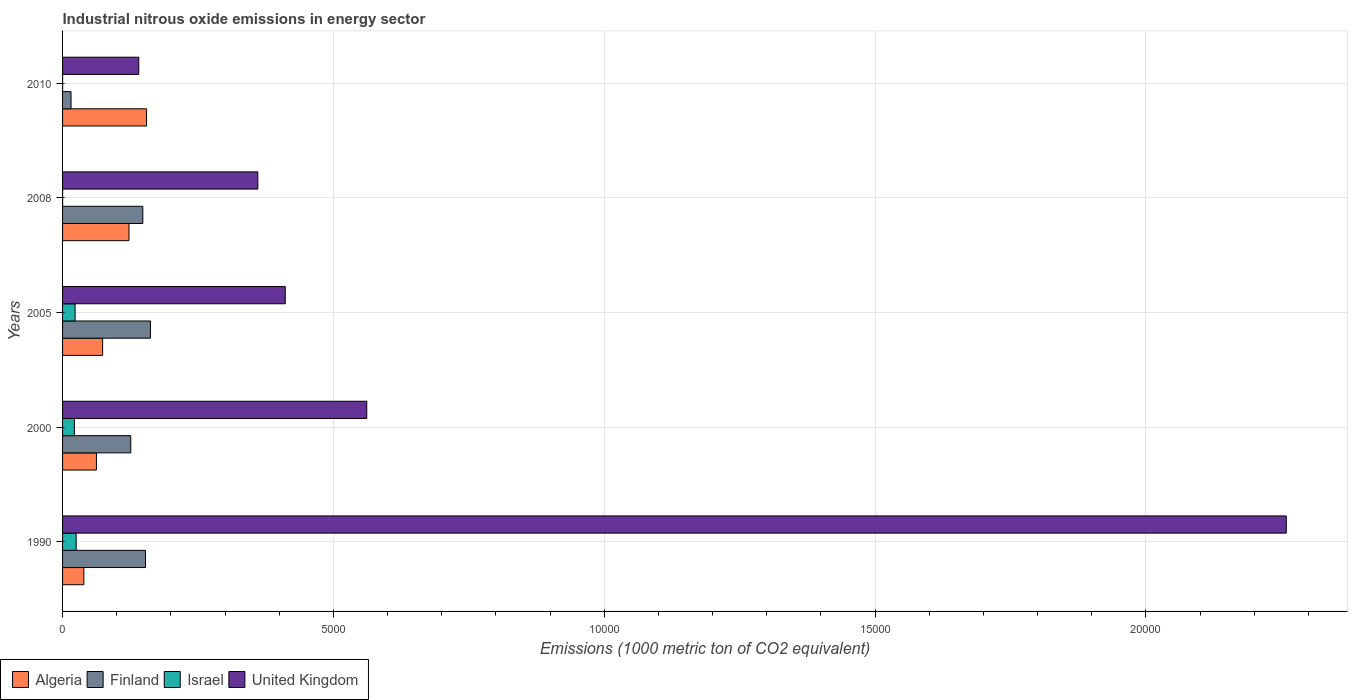How many different coloured bars are there?
Ensure brevity in your answer.  4. How many groups of bars are there?
Provide a succinct answer. 5. Are the number of bars per tick equal to the number of legend labels?
Give a very brief answer. Yes. Are the number of bars on each tick of the Y-axis equal?
Keep it short and to the point. Yes. How many bars are there on the 2nd tick from the top?
Offer a very short reply. 4. What is the label of the 4th group of bars from the top?
Your answer should be very brief. 2000. What is the amount of industrial nitrous oxide emitted in Algeria in 1990?
Ensure brevity in your answer.  393.4. Across all years, what is the maximum amount of industrial nitrous oxide emitted in Finland?
Your answer should be very brief. 1622.4. Across all years, what is the minimum amount of industrial nitrous oxide emitted in Algeria?
Make the answer very short. 393.4. In which year was the amount of industrial nitrous oxide emitted in Algeria maximum?
Offer a terse response. 2010. What is the total amount of industrial nitrous oxide emitted in Algeria in the graph?
Keep it short and to the point. 4534.8. What is the difference between the amount of industrial nitrous oxide emitted in Finland in 2000 and that in 2008?
Ensure brevity in your answer.  -222.1. What is the difference between the amount of industrial nitrous oxide emitted in Finland in 2000 and the amount of industrial nitrous oxide emitted in United Kingdom in 2008?
Your answer should be compact. -2345.2. What is the average amount of industrial nitrous oxide emitted in United Kingdom per year?
Make the answer very short. 7466.28. In the year 2005, what is the difference between the amount of industrial nitrous oxide emitted in Algeria and amount of industrial nitrous oxide emitted in Finland?
Keep it short and to the point. -882.8. What is the ratio of the amount of industrial nitrous oxide emitted in Finland in 2000 to that in 2008?
Provide a short and direct response. 0.85. Is the difference between the amount of industrial nitrous oxide emitted in Algeria in 1990 and 2005 greater than the difference between the amount of industrial nitrous oxide emitted in Finland in 1990 and 2005?
Give a very brief answer. No. What is the difference between the highest and the second highest amount of industrial nitrous oxide emitted in Finland?
Give a very brief answer. 91.5. What is the difference between the highest and the lowest amount of industrial nitrous oxide emitted in United Kingdom?
Provide a short and direct response. 2.12e+04. Is the sum of the amount of industrial nitrous oxide emitted in United Kingdom in 1990 and 2005 greater than the maximum amount of industrial nitrous oxide emitted in Israel across all years?
Your answer should be very brief. Yes. What does the 3rd bar from the top in 1990 represents?
Give a very brief answer. Finland. What does the 1st bar from the bottom in 2000 represents?
Your response must be concise. Algeria. Is it the case that in every year, the sum of the amount of industrial nitrous oxide emitted in United Kingdom and amount of industrial nitrous oxide emitted in Israel is greater than the amount of industrial nitrous oxide emitted in Algeria?
Offer a very short reply. No. Are all the bars in the graph horizontal?
Offer a very short reply. Yes. Does the graph contain any zero values?
Give a very brief answer. No. Does the graph contain grids?
Offer a terse response. Yes. Where does the legend appear in the graph?
Offer a terse response. Bottom left. What is the title of the graph?
Your answer should be very brief. Industrial nitrous oxide emissions in energy sector. What is the label or title of the X-axis?
Ensure brevity in your answer.  Emissions (1000 metric ton of CO2 equivalent). What is the Emissions (1000 metric ton of CO2 equivalent) in Algeria in 1990?
Your answer should be very brief. 393.4. What is the Emissions (1000 metric ton of CO2 equivalent) in Finland in 1990?
Your answer should be very brief. 1530.9. What is the Emissions (1000 metric ton of CO2 equivalent) of Israel in 1990?
Your response must be concise. 251.1. What is the Emissions (1000 metric ton of CO2 equivalent) of United Kingdom in 1990?
Give a very brief answer. 2.26e+04. What is the Emissions (1000 metric ton of CO2 equivalent) in Algeria in 2000?
Offer a terse response. 625. What is the Emissions (1000 metric ton of CO2 equivalent) of Finland in 2000?
Your answer should be very brief. 1259.4. What is the Emissions (1000 metric ton of CO2 equivalent) in Israel in 2000?
Provide a short and direct response. 217.6. What is the Emissions (1000 metric ton of CO2 equivalent) in United Kingdom in 2000?
Keep it short and to the point. 5616. What is the Emissions (1000 metric ton of CO2 equivalent) in Algeria in 2005?
Make the answer very short. 739.6. What is the Emissions (1000 metric ton of CO2 equivalent) in Finland in 2005?
Make the answer very short. 1622.4. What is the Emissions (1000 metric ton of CO2 equivalent) of Israel in 2005?
Give a very brief answer. 231.6. What is the Emissions (1000 metric ton of CO2 equivalent) of United Kingdom in 2005?
Ensure brevity in your answer.  4111.2. What is the Emissions (1000 metric ton of CO2 equivalent) of Algeria in 2008?
Provide a succinct answer. 1226.2. What is the Emissions (1000 metric ton of CO2 equivalent) of Finland in 2008?
Make the answer very short. 1481.5. What is the Emissions (1000 metric ton of CO2 equivalent) of United Kingdom in 2008?
Provide a succinct answer. 3604.6. What is the Emissions (1000 metric ton of CO2 equivalent) of Algeria in 2010?
Offer a very short reply. 1550.6. What is the Emissions (1000 metric ton of CO2 equivalent) in Finland in 2010?
Keep it short and to the point. 156.3. What is the Emissions (1000 metric ton of CO2 equivalent) in Israel in 2010?
Your answer should be compact. 0.6. What is the Emissions (1000 metric ton of CO2 equivalent) of United Kingdom in 2010?
Make the answer very short. 1406.6. Across all years, what is the maximum Emissions (1000 metric ton of CO2 equivalent) in Algeria?
Provide a succinct answer. 1550.6. Across all years, what is the maximum Emissions (1000 metric ton of CO2 equivalent) of Finland?
Provide a succinct answer. 1622.4. Across all years, what is the maximum Emissions (1000 metric ton of CO2 equivalent) in Israel?
Make the answer very short. 251.1. Across all years, what is the maximum Emissions (1000 metric ton of CO2 equivalent) of United Kingdom?
Keep it short and to the point. 2.26e+04. Across all years, what is the minimum Emissions (1000 metric ton of CO2 equivalent) in Algeria?
Your response must be concise. 393.4. Across all years, what is the minimum Emissions (1000 metric ton of CO2 equivalent) of Finland?
Your answer should be compact. 156.3. Across all years, what is the minimum Emissions (1000 metric ton of CO2 equivalent) of United Kingdom?
Ensure brevity in your answer.  1406.6. What is the total Emissions (1000 metric ton of CO2 equivalent) of Algeria in the graph?
Your answer should be very brief. 4534.8. What is the total Emissions (1000 metric ton of CO2 equivalent) of Finland in the graph?
Your answer should be compact. 6050.5. What is the total Emissions (1000 metric ton of CO2 equivalent) of Israel in the graph?
Provide a short and direct response. 701.9. What is the total Emissions (1000 metric ton of CO2 equivalent) of United Kingdom in the graph?
Your answer should be very brief. 3.73e+04. What is the difference between the Emissions (1000 metric ton of CO2 equivalent) in Algeria in 1990 and that in 2000?
Provide a short and direct response. -231.6. What is the difference between the Emissions (1000 metric ton of CO2 equivalent) of Finland in 1990 and that in 2000?
Provide a succinct answer. 271.5. What is the difference between the Emissions (1000 metric ton of CO2 equivalent) in Israel in 1990 and that in 2000?
Make the answer very short. 33.5. What is the difference between the Emissions (1000 metric ton of CO2 equivalent) of United Kingdom in 1990 and that in 2000?
Offer a terse response. 1.70e+04. What is the difference between the Emissions (1000 metric ton of CO2 equivalent) in Algeria in 1990 and that in 2005?
Provide a succinct answer. -346.2. What is the difference between the Emissions (1000 metric ton of CO2 equivalent) in Finland in 1990 and that in 2005?
Offer a very short reply. -91.5. What is the difference between the Emissions (1000 metric ton of CO2 equivalent) of United Kingdom in 1990 and that in 2005?
Provide a succinct answer. 1.85e+04. What is the difference between the Emissions (1000 metric ton of CO2 equivalent) of Algeria in 1990 and that in 2008?
Offer a very short reply. -832.8. What is the difference between the Emissions (1000 metric ton of CO2 equivalent) in Finland in 1990 and that in 2008?
Make the answer very short. 49.4. What is the difference between the Emissions (1000 metric ton of CO2 equivalent) of Israel in 1990 and that in 2008?
Make the answer very short. 250.1. What is the difference between the Emissions (1000 metric ton of CO2 equivalent) in United Kingdom in 1990 and that in 2008?
Keep it short and to the point. 1.90e+04. What is the difference between the Emissions (1000 metric ton of CO2 equivalent) in Algeria in 1990 and that in 2010?
Give a very brief answer. -1157.2. What is the difference between the Emissions (1000 metric ton of CO2 equivalent) of Finland in 1990 and that in 2010?
Offer a terse response. 1374.6. What is the difference between the Emissions (1000 metric ton of CO2 equivalent) in Israel in 1990 and that in 2010?
Your answer should be very brief. 250.5. What is the difference between the Emissions (1000 metric ton of CO2 equivalent) in United Kingdom in 1990 and that in 2010?
Give a very brief answer. 2.12e+04. What is the difference between the Emissions (1000 metric ton of CO2 equivalent) in Algeria in 2000 and that in 2005?
Offer a terse response. -114.6. What is the difference between the Emissions (1000 metric ton of CO2 equivalent) of Finland in 2000 and that in 2005?
Keep it short and to the point. -363. What is the difference between the Emissions (1000 metric ton of CO2 equivalent) of Israel in 2000 and that in 2005?
Provide a succinct answer. -14. What is the difference between the Emissions (1000 metric ton of CO2 equivalent) in United Kingdom in 2000 and that in 2005?
Offer a very short reply. 1504.8. What is the difference between the Emissions (1000 metric ton of CO2 equivalent) of Algeria in 2000 and that in 2008?
Your answer should be compact. -601.2. What is the difference between the Emissions (1000 metric ton of CO2 equivalent) of Finland in 2000 and that in 2008?
Make the answer very short. -222.1. What is the difference between the Emissions (1000 metric ton of CO2 equivalent) of Israel in 2000 and that in 2008?
Give a very brief answer. 216.6. What is the difference between the Emissions (1000 metric ton of CO2 equivalent) of United Kingdom in 2000 and that in 2008?
Make the answer very short. 2011.4. What is the difference between the Emissions (1000 metric ton of CO2 equivalent) in Algeria in 2000 and that in 2010?
Your answer should be compact. -925.6. What is the difference between the Emissions (1000 metric ton of CO2 equivalent) of Finland in 2000 and that in 2010?
Your answer should be compact. 1103.1. What is the difference between the Emissions (1000 metric ton of CO2 equivalent) of Israel in 2000 and that in 2010?
Offer a very short reply. 217. What is the difference between the Emissions (1000 metric ton of CO2 equivalent) of United Kingdom in 2000 and that in 2010?
Offer a terse response. 4209.4. What is the difference between the Emissions (1000 metric ton of CO2 equivalent) of Algeria in 2005 and that in 2008?
Make the answer very short. -486.6. What is the difference between the Emissions (1000 metric ton of CO2 equivalent) of Finland in 2005 and that in 2008?
Make the answer very short. 140.9. What is the difference between the Emissions (1000 metric ton of CO2 equivalent) in Israel in 2005 and that in 2008?
Your answer should be compact. 230.6. What is the difference between the Emissions (1000 metric ton of CO2 equivalent) of United Kingdom in 2005 and that in 2008?
Provide a succinct answer. 506.6. What is the difference between the Emissions (1000 metric ton of CO2 equivalent) in Algeria in 2005 and that in 2010?
Offer a terse response. -811. What is the difference between the Emissions (1000 metric ton of CO2 equivalent) of Finland in 2005 and that in 2010?
Keep it short and to the point. 1466.1. What is the difference between the Emissions (1000 metric ton of CO2 equivalent) of Israel in 2005 and that in 2010?
Your answer should be compact. 231. What is the difference between the Emissions (1000 metric ton of CO2 equivalent) of United Kingdom in 2005 and that in 2010?
Your answer should be compact. 2704.6. What is the difference between the Emissions (1000 metric ton of CO2 equivalent) in Algeria in 2008 and that in 2010?
Offer a very short reply. -324.4. What is the difference between the Emissions (1000 metric ton of CO2 equivalent) of Finland in 2008 and that in 2010?
Offer a terse response. 1325.2. What is the difference between the Emissions (1000 metric ton of CO2 equivalent) in United Kingdom in 2008 and that in 2010?
Make the answer very short. 2198. What is the difference between the Emissions (1000 metric ton of CO2 equivalent) in Algeria in 1990 and the Emissions (1000 metric ton of CO2 equivalent) in Finland in 2000?
Give a very brief answer. -866. What is the difference between the Emissions (1000 metric ton of CO2 equivalent) in Algeria in 1990 and the Emissions (1000 metric ton of CO2 equivalent) in Israel in 2000?
Ensure brevity in your answer.  175.8. What is the difference between the Emissions (1000 metric ton of CO2 equivalent) of Algeria in 1990 and the Emissions (1000 metric ton of CO2 equivalent) of United Kingdom in 2000?
Make the answer very short. -5222.6. What is the difference between the Emissions (1000 metric ton of CO2 equivalent) of Finland in 1990 and the Emissions (1000 metric ton of CO2 equivalent) of Israel in 2000?
Make the answer very short. 1313.3. What is the difference between the Emissions (1000 metric ton of CO2 equivalent) in Finland in 1990 and the Emissions (1000 metric ton of CO2 equivalent) in United Kingdom in 2000?
Your response must be concise. -4085.1. What is the difference between the Emissions (1000 metric ton of CO2 equivalent) of Israel in 1990 and the Emissions (1000 metric ton of CO2 equivalent) of United Kingdom in 2000?
Make the answer very short. -5364.9. What is the difference between the Emissions (1000 metric ton of CO2 equivalent) of Algeria in 1990 and the Emissions (1000 metric ton of CO2 equivalent) of Finland in 2005?
Make the answer very short. -1229. What is the difference between the Emissions (1000 metric ton of CO2 equivalent) of Algeria in 1990 and the Emissions (1000 metric ton of CO2 equivalent) of Israel in 2005?
Give a very brief answer. 161.8. What is the difference between the Emissions (1000 metric ton of CO2 equivalent) of Algeria in 1990 and the Emissions (1000 metric ton of CO2 equivalent) of United Kingdom in 2005?
Make the answer very short. -3717.8. What is the difference between the Emissions (1000 metric ton of CO2 equivalent) in Finland in 1990 and the Emissions (1000 metric ton of CO2 equivalent) in Israel in 2005?
Your answer should be very brief. 1299.3. What is the difference between the Emissions (1000 metric ton of CO2 equivalent) in Finland in 1990 and the Emissions (1000 metric ton of CO2 equivalent) in United Kingdom in 2005?
Provide a succinct answer. -2580.3. What is the difference between the Emissions (1000 metric ton of CO2 equivalent) of Israel in 1990 and the Emissions (1000 metric ton of CO2 equivalent) of United Kingdom in 2005?
Provide a succinct answer. -3860.1. What is the difference between the Emissions (1000 metric ton of CO2 equivalent) in Algeria in 1990 and the Emissions (1000 metric ton of CO2 equivalent) in Finland in 2008?
Offer a very short reply. -1088.1. What is the difference between the Emissions (1000 metric ton of CO2 equivalent) of Algeria in 1990 and the Emissions (1000 metric ton of CO2 equivalent) of Israel in 2008?
Give a very brief answer. 392.4. What is the difference between the Emissions (1000 metric ton of CO2 equivalent) of Algeria in 1990 and the Emissions (1000 metric ton of CO2 equivalent) of United Kingdom in 2008?
Offer a terse response. -3211.2. What is the difference between the Emissions (1000 metric ton of CO2 equivalent) in Finland in 1990 and the Emissions (1000 metric ton of CO2 equivalent) in Israel in 2008?
Your answer should be compact. 1529.9. What is the difference between the Emissions (1000 metric ton of CO2 equivalent) of Finland in 1990 and the Emissions (1000 metric ton of CO2 equivalent) of United Kingdom in 2008?
Keep it short and to the point. -2073.7. What is the difference between the Emissions (1000 metric ton of CO2 equivalent) of Israel in 1990 and the Emissions (1000 metric ton of CO2 equivalent) of United Kingdom in 2008?
Your answer should be compact. -3353.5. What is the difference between the Emissions (1000 metric ton of CO2 equivalent) of Algeria in 1990 and the Emissions (1000 metric ton of CO2 equivalent) of Finland in 2010?
Make the answer very short. 237.1. What is the difference between the Emissions (1000 metric ton of CO2 equivalent) of Algeria in 1990 and the Emissions (1000 metric ton of CO2 equivalent) of Israel in 2010?
Provide a succinct answer. 392.8. What is the difference between the Emissions (1000 metric ton of CO2 equivalent) of Algeria in 1990 and the Emissions (1000 metric ton of CO2 equivalent) of United Kingdom in 2010?
Offer a terse response. -1013.2. What is the difference between the Emissions (1000 metric ton of CO2 equivalent) of Finland in 1990 and the Emissions (1000 metric ton of CO2 equivalent) of Israel in 2010?
Provide a succinct answer. 1530.3. What is the difference between the Emissions (1000 metric ton of CO2 equivalent) in Finland in 1990 and the Emissions (1000 metric ton of CO2 equivalent) in United Kingdom in 2010?
Offer a terse response. 124.3. What is the difference between the Emissions (1000 metric ton of CO2 equivalent) of Israel in 1990 and the Emissions (1000 metric ton of CO2 equivalent) of United Kingdom in 2010?
Provide a succinct answer. -1155.5. What is the difference between the Emissions (1000 metric ton of CO2 equivalent) in Algeria in 2000 and the Emissions (1000 metric ton of CO2 equivalent) in Finland in 2005?
Provide a succinct answer. -997.4. What is the difference between the Emissions (1000 metric ton of CO2 equivalent) of Algeria in 2000 and the Emissions (1000 metric ton of CO2 equivalent) of Israel in 2005?
Your response must be concise. 393.4. What is the difference between the Emissions (1000 metric ton of CO2 equivalent) in Algeria in 2000 and the Emissions (1000 metric ton of CO2 equivalent) in United Kingdom in 2005?
Ensure brevity in your answer.  -3486.2. What is the difference between the Emissions (1000 metric ton of CO2 equivalent) of Finland in 2000 and the Emissions (1000 metric ton of CO2 equivalent) of Israel in 2005?
Make the answer very short. 1027.8. What is the difference between the Emissions (1000 metric ton of CO2 equivalent) in Finland in 2000 and the Emissions (1000 metric ton of CO2 equivalent) in United Kingdom in 2005?
Make the answer very short. -2851.8. What is the difference between the Emissions (1000 metric ton of CO2 equivalent) of Israel in 2000 and the Emissions (1000 metric ton of CO2 equivalent) of United Kingdom in 2005?
Provide a succinct answer. -3893.6. What is the difference between the Emissions (1000 metric ton of CO2 equivalent) in Algeria in 2000 and the Emissions (1000 metric ton of CO2 equivalent) in Finland in 2008?
Your answer should be compact. -856.5. What is the difference between the Emissions (1000 metric ton of CO2 equivalent) of Algeria in 2000 and the Emissions (1000 metric ton of CO2 equivalent) of Israel in 2008?
Ensure brevity in your answer.  624. What is the difference between the Emissions (1000 metric ton of CO2 equivalent) in Algeria in 2000 and the Emissions (1000 metric ton of CO2 equivalent) in United Kingdom in 2008?
Ensure brevity in your answer.  -2979.6. What is the difference between the Emissions (1000 metric ton of CO2 equivalent) of Finland in 2000 and the Emissions (1000 metric ton of CO2 equivalent) of Israel in 2008?
Offer a terse response. 1258.4. What is the difference between the Emissions (1000 metric ton of CO2 equivalent) of Finland in 2000 and the Emissions (1000 metric ton of CO2 equivalent) of United Kingdom in 2008?
Give a very brief answer. -2345.2. What is the difference between the Emissions (1000 metric ton of CO2 equivalent) in Israel in 2000 and the Emissions (1000 metric ton of CO2 equivalent) in United Kingdom in 2008?
Provide a short and direct response. -3387. What is the difference between the Emissions (1000 metric ton of CO2 equivalent) of Algeria in 2000 and the Emissions (1000 metric ton of CO2 equivalent) of Finland in 2010?
Provide a succinct answer. 468.7. What is the difference between the Emissions (1000 metric ton of CO2 equivalent) of Algeria in 2000 and the Emissions (1000 metric ton of CO2 equivalent) of Israel in 2010?
Provide a succinct answer. 624.4. What is the difference between the Emissions (1000 metric ton of CO2 equivalent) in Algeria in 2000 and the Emissions (1000 metric ton of CO2 equivalent) in United Kingdom in 2010?
Ensure brevity in your answer.  -781.6. What is the difference between the Emissions (1000 metric ton of CO2 equivalent) of Finland in 2000 and the Emissions (1000 metric ton of CO2 equivalent) of Israel in 2010?
Your answer should be very brief. 1258.8. What is the difference between the Emissions (1000 metric ton of CO2 equivalent) of Finland in 2000 and the Emissions (1000 metric ton of CO2 equivalent) of United Kingdom in 2010?
Provide a succinct answer. -147.2. What is the difference between the Emissions (1000 metric ton of CO2 equivalent) of Israel in 2000 and the Emissions (1000 metric ton of CO2 equivalent) of United Kingdom in 2010?
Your answer should be very brief. -1189. What is the difference between the Emissions (1000 metric ton of CO2 equivalent) in Algeria in 2005 and the Emissions (1000 metric ton of CO2 equivalent) in Finland in 2008?
Provide a short and direct response. -741.9. What is the difference between the Emissions (1000 metric ton of CO2 equivalent) in Algeria in 2005 and the Emissions (1000 metric ton of CO2 equivalent) in Israel in 2008?
Provide a succinct answer. 738.6. What is the difference between the Emissions (1000 metric ton of CO2 equivalent) of Algeria in 2005 and the Emissions (1000 metric ton of CO2 equivalent) of United Kingdom in 2008?
Keep it short and to the point. -2865. What is the difference between the Emissions (1000 metric ton of CO2 equivalent) in Finland in 2005 and the Emissions (1000 metric ton of CO2 equivalent) in Israel in 2008?
Give a very brief answer. 1621.4. What is the difference between the Emissions (1000 metric ton of CO2 equivalent) in Finland in 2005 and the Emissions (1000 metric ton of CO2 equivalent) in United Kingdom in 2008?
Offer a terse response. -1982.2. What is the difference between the Emissions (1000 metric ton of CO2 equivalent) of Israel in 2005 and the Emissions (1000 metric ton of CO2 equivalent) of United Kingdom in 2008?
Keep it short and to the point. -3373. What is the difference between the Emissions (1000 metric ton of CO2 equivalent) in Algeria in 2005 and the Emissions (1000 metric ton of CO2 equivalent) in Finland in 2010?
Ensure brevity in your answer.  583.3. What is the difference between the Emissions (1000 metric ton of CO2 equivalent) of Algeria in 2005 and the Emissions (1000 metric ton of CO2 equivalent) of Israel in 2010?
Offer a very short reply. 739. What is the difference between the Emissions (1000 metric ton of CO2 equivalent) of Algeria in 2005 and the Emissions (1000 metric ton of CO2 equivalent) of United Kingdom in 2010?
Keep it short and to the point. -667. What is the difference between the Emissions (1000 metric ton of CO2 equivalent) of Finland in 2005 and the Emissions (1000 metric ton of CO2 equivalent) of Israel in 2010?
Your answer should be compact. 1621.8. What is the difference between the Emissions (1000 metric ton of CO2 equivalent) in Finland in 2005 and the Emissions (1000 metric ton of CO2 equivalent) in United Kingdom in 2010?
Provide a succinct answer. 215.8. What is the difference between the Emissions (1000 metric ton of CO2 equivalent) of Israel in 2005 and the Emissions (1000 metric ton of CO2 equivalent) of United Kingdom in 2010?
Provide a short and direct response. -1175. What is the difference between the Emissions (1000 metric ton of CO2 equivalent) in Algeria in 2008 and the Emissions (1000 metric ton of CO2 equivalent) in Finland in 2010?
Keep it short and to the point. 1069.9. What is the difference between the Emissions (1000 metric ton of CO2 equivalent) of Algeria in 2008 and the Emissions (1000 metric ton of CO2 equivalent) of Israel in 2010?
Provide a short and direct response. 1225.6. What is the difference between the Emissions (1000 metric ton of CO2 equivalent) in Algeria in 2008 and the Emissions (1000 metric ton of CO2 equivalent) in United Kingdom in 2010?
Keep it short and to the point. -180.4. What is the difference between the Emissions (1000 metric ton of CO2 equivalent) of Finland in 2008 and the Emissions (1000 metric ton of CO2 equivalent) of Israel in 2010?
Give a very brief answer. 1480.9. What is the difference between the Emissions (1000 metric ton of CO2 equivalent) of Finland in 2008 and the Emissions (1000 metric ton of CO2 equivalent) of United Kingdom in 2010?
Offer a terse response. 74.9. What is the difference between the Emissions (1000 metric ton of CO2 equivalent) in Israel in 2008 and the Emissions (1000 metric ton of CO2 equivalent) in United Kingdom in 2010?
Your response must be concise. -1405.6. What is the average Emissions (1000 metric ton of CO2 equivalent) in Algeria per year?
Ensure brevity in your answer.  906.96. What is the average Emissions (1000 metric ton of CO2 equivalent) of Finland per year?
Your response must be concise. 1210.1. What is the average Emissions (1000 metric ton of CO2 equivalent) in Israel per year?
Your answer should be very brief. 140.38. What is the average Emissions (1000 metric ton of CO2 equivalent) in United Kingdom per year?
Give a very brief answer. 7466.28. In the year 1990, what is the difference between the Emissions (1000 metric ton of CO2 equivalent) of Algeria and Emissions (1000 metric ton of CO2 equivalent) of Finland?
Your answer should be very brief. -1137.5. In the year 1990, what is the difference between the Emissions (1000 metric ton of CO2 equivalent) of Algeria and Emissions (1000 metric ton of CO2 equivalent) of Israel?
Ensure brevity in your answer.  142.3. In the year 1990, what is the difference between the Emissions (1000 metric ton of CO2 equivalent) in Algeria and Emissions (1000 metric ton of CO2 equivalent) in United Kingdom?
Provide a short and direct response. -2.22e+04. In the year 1990, what is the difference between the Emissions (1000 metric ton of CO2 equivalent) of Finland and Emissions (1000 metric ton of CO2 equivalent) of Israel?
Your response must be concise. 1279.8. In the year 1990, what is the difference between the Emissions (1000 metric ton of CO2 equivalent) of Finland and Emissions (1000 metric ton of CO2 equivalent) of United Kingdom?
Provide a short and direct response. -2.11e+04. In the year 1990, what is the difference between the Emissions (1000 metric ton of CO2 equivalent) in Israel and Emissions (1000 metric ton of CO2 equivalent) in United Kingdom?
Make the answer very short. -2.23e+04. In the year 2000, what is the difference between the Emissions (1000 metric ton of CO2 equivalent) in Algeria and Emissions (1000 metric ton of CO2 equivalent) in Finland?
Your answer should be very brief. -634.4. In the year 2000, what is the difference between the Emissions (1000 metric ton of CO2 equivalent) of Algeria and Emissions (1000 metric ton of CO2 equivalent) of Israel?
Offer a very short reply. 407.4. In the year 2000, what is the difference between the Emissions (1000 metric ton of CO2 equivalent) in Algeria and Emissions (1000 metric ton of CO2 equivalent) in United Kingdom?
Offer a very short reply. -4991. In the year 2000, what is the difference between the Emissions (1000 metric ton of CO2 equivalent) of Finland and Emissions (1000 metric ton of CO2 equivalent) of Israel?
Your response must be concise. 1041.8. In the year 2000, what is the difference between the Emissions (1000 metric ton of CO2 equivalent) in Finland and Emissions (1000 metric ton of CO2 equivalent) in United Kingdom?
Ensure brevity in your answer.  -4356.6. In the year 2000, what is the difference between the Emissions (1000 metric ton of CO2 equivalent) in Israel and Emissions (1000 metric ton of CO2 equivalent) in United Kingdom?
Your response must be concise. -5398.4. In the year 2005, what is the difference between the Emissions (1000 metric ton of CO2 equivalent) of Algeria and Emissions (1000 metric ton of CO2 equivalent) of Finland?
Offer a terse response. -882.8. In the year 2005, what is the difference between the Emissions (1000 metric ton of CO2 equivalent) in Algeria and Emissions (1000 metric ton of CO2 equivalent) in Israel?
Your answer should be very brief. 508. In the year 2005, what is the difference between the Emissions (1000 metric ton of CO2 equivalent) of Algeria and Emissions (1000 metric ton of CO2 equivalent) of United Kingdom?
Offer a very short reply. -3371.6. In the year 2005, what is the difference between the Emissions (1000 metric ton of CO2 equivalent) in Finland and Emissions (1000 metric ton of CO2 equivalent) in Israel?
Ensure brevity in your answer.  1390.8. In the year 2005, what is the difference between the Emissions (1000 metric ton of CO2 equivalent) in Finland and Emissions (1000 metric ton of CO2 equivalent) in United Kingdom?
Offer a terse response. -2488.8. In the year 2005, what is the difference between the Emissions (1000 metric ton of CO2 equivalent) in Israel and Emissions (1000 metric ton of CO2 equivalent) in United Kingdom?
Your answer should be compact. -3879.6. In the year 2008, what is the difference between the Emissions (1000 metric ton of CO2 equivalent) in Algeria and Emissions (1000 metric ton of CO2 equivalent) in Finland?
Offer a terse response. -255.3. In the year 2008, what is the difference between the Emissions (1000 metric ton of CO2 equivalent) of Algeria and Emissions (1000 metric ton of CO2 equivalent) of Israel?
Ensure brevity in your answer.  1225.2. In the year 2008, what is the difference between the Emissions (1000 metric ton of CO2 equivalent) in Algeria and Emissions (1000 metric ton of CO2 equivalent) in United Kingdom?
Make the answer very short. -2378.4. In the year 2008, what is the difference between the Emissions (1000 metric ton of CO2 equivalent) of Finland and Emissions (1000 metric ton of CO2 equivalent) of Israel?
Make the answer very short. 1480.5. In the year 2008, what is the difference between the Emissions (1000 metric ton of CO2 equivalent) in Finland and Emissions (1000 metric ton of CO2 equivalent) in United Kingdom?
Keep it short and to the point. -2123.1. In the year 2008, what is the difference between the Emissions (1000 metric ton of CO2 equivalent) of Israel and Emissions (1000 metric ton of CO2 equivalent) of United Kingdom?
Provide a succinct answer. -3603.6. In the year 2010, what is the difference between the Emissions (1000 metric ton of CO2 equivalent) of Algeria and Emissions (1000 metric ton of CO2 equivalent) of Finland?
Provide a short and direct response. 1394.3. In the year 2010, what is the difference between the Emissions (1000 metric ton of CO2 equivalent) in Algeria and Emissions (1000 metric ton of CO2 equivalent) in Israel?
Ensure brevity in your answer.  1550. In the year 2010, what is the difference between the Emissions (1000 metric ton of CO2 equivalent) of Algeria and Emissions (1000 metric ton of CO2 equivalent) of United Kingdom?
Your answer should be compact. 144. In the year 2010, what is the difference between the Emissions (1000 metric ton of CO2 equivalent) in Finland and Emissions (1000 metric ton of CO2 equivalent) in Israel?
Ensure brevity in your answer.  155.7. In the year 2010, what is the difference between the Emissions (1000 metric ton of CO2 equivalent) in Finland and Emissions (1000 metric ton of CO2 equivalent) in United Kingdom?
Your answer should be compact. -1250.3. In the year 2010, what is the difference between the Emissions (1000 metric ton of CO2 equivalent) of Israel and Emissions (1000 metric ton of CO2 equivalent) of United Kingdom?
Your answer should be very brief. -1406. What is the ratio of the Emissions (1000 metric ton of CO2 equivalent) in Algeria in 1990 to that in 2000?
Your response must be concise. 0.63. What is the ratio of the Emissions (1000 metric ton of CO2 equivalent) of Finland in 1990 to that in 2000?
Your answer should be compact. 1.22. What is the ratio of the Emissions (1000 metric ton of CO2 equivalent) in Israel in 1990 to that in 2000?
Give a very brief answer. 1.15. What is the ratio of the Emissions (1000 metric ton of CO2 equivalent) in United Kingdom in 1990 to that in 2000?
Provide a succinct answer. 4.02. What is the ratio of the Emissions (1000 metric ton of CO2 equivalent) in Algeria in 1990 to that in 2005?
Your answer should be compact. 0.53. What is the ratio of the Emissions (1000 metric ton of CO2 equivalent) of Finland in 1990 to that in 2005?
Your answer should be very brief. 0.94. What is the ratio of the Emissions (1000 metric ton of CO2 equivalent) in Israel in 1990 to that in 2005?
Your answer should be compact. 1.08. What is the ratio of the Emissions (1000 metric ton of CO2 equivalent) of United Kingdom in 1990 to that in 2005?
Make the answer very short. 5.5. What is the ratio of the Emissions (1000 metric ton of CO2 equivalent) in Algeria in 1990 to that in 2008?
Your answer should be compact. 0.32. What is the ratio of the Emissions (1000 metric ton of CO2 equivalent) of Finland in 1990 to that in 2008?
Offer a terse response. 1.03. What is the ratio of the Emissions (1000 metric ton of CO2 equivalent) of Israel in 1990 to that in 2008?
Your answer should be compact. 251.1. What is the ratio of the Emissions (1000 metric ton of CO2 equivalent) in United Kingdom in 1990 to that in 2008?
Offer a terse response. 6.27. What is the ratio of the Emissions (1000 metric ton of CO2 equivalent) of Algeria in 1990 to that in 2010?
Your answer should be compact. 0.25. What is the ratio of the Emissions (1000 metric ton of CO2 equivalent) of Finland in 1990 to that in 2010?
Offer a terse response. 9.79. What is the ratio of the Emissions (1000 metric ton of CO2 equivalent) in Israel in 1990 to that in 2010?
Make the answer very short. 418.5. What is the ratio of the Emissions (1000 metric ton of CO2 equivalent) in United Kingdom in 1990 to that in 2010?
Offer a very short reply. 16.06. What is the ratio of the Emissions (1000 metric ton of CO2 equivalent) in Algeria in 2000 to that in 2005?
Ensure brevity in your answer.  0.85. What is the ratio of the Emissions (1000 metric ton of CO2 equivalent) of Finland in 2000 to that in 2005?
Keep it short and to the point. 0.78. What is the ratio of the Emissions (1000 metric ton of CO2 equivalent) in Israel in 2000 to that in 2005?
Your answer should be compact. 0.94. What is the ratio of the Emissions (1000 metric ton of CO2 equivalent) of United Kingdom in 2000 to that in 2005?
Give a very brief answer. 1.37. What is the ratio of the Emissions (1000 metric ton of CO2 equivalent) of Algeria in 2000 to that in 2008?
Provide a succinct answer. 0.51. What is the ratio of the Emissions (1000 metric ton of CO2 equivalent) of Finland in 2000 to that in 2008?
Provide a short and direct response. 0.85. What is the ratio of the Emissions (1000 metric ton of CO2 equivalent) in Israel in 2000 to that in 2008?
Ensure brevity in your answer.  217.6. What is the ratio of the Emissions (1000 metric ton of CO2 equivalent) in United Kingdom in 2000 to that in 2008?
Your answer should be very brief. 1.56. What is the ratio of the Emissions (1000 metric ton of CO2 equivalent) in Algeria in 2000 to that in 2010?
Make the answer very short. 0.4. What is the ratio of the Emissions (1000 metric ton of CO2 equivalent) in Finland in 2000 to that in 2010?
Offer a very short reply. 8.06. What is the ratio of the Emissions (1000 metric ton of CO2 equivalent) in Israel in 2000 to that in 2010?
Offer a terse response. 362.67. What is the ratio of the Emissions (1000 metric ton of CO2 equivalent) in United Kingdom in 2000 to that in 2010?
Keep it short and to the point. 3.99. What is the ratio of the Emissions (1000 metric ton of CO2 equivalent) in Algeria in 2005 to that in 2008?
Offer a very short reply. 0.6. What is the ratio of the Emissions (1000 metric ton of CO2 equivalent) of Finland in 2005 to that in 2008?
Your answer should be compact. 1.1. What is the ratio of the Emissions (1000 metric ton of CO2 equivalent) in Israel in 2005 to that in 2008?
Give a very brief answer. 231.6. What is the ratio of the Emissions (1000 metric ton of CO2 equivalent) of United Kingdom in 2005 to that in 2008?
Keep it short and to the point. 1.14. What is the ratio of the Emissions (1000 metric ton of CO2 equivalent) of Algeria in 2005 to that in 2010?
Your answer should be compact. 0.48. What is the ratio of the Emissions (1000 metric ton of CO2 equivalent) of Finland in 2005 to that in 2010?
Your answer should be compact. 10.38. What is the ratio of the Emissions (1000 metric ton of CO2 equivalent) of Israel in 2005 to that in 2010?
Your answer should be compact. 386. What is the ratio of the Emissions (1000 metric ton of CO2 equivalent) in United Kingdom in 2005 to that in 2010?
Provide a short and direct response. 2.92. What is the ratio of the Emissions (1000 metric ton of CO2 equivalent) in Algeria in 2008 to that in 2010?
Give a very brief answer. 0.79. What is the ratio of the Emissions (1000 metric ton of CO2 equivalent) of Finland in 2008 to that in 2010?
Make the answer very short. 9.48. What is the ratio of the Emissions (1000 metric ton of CO2 equivalent) in Israel in 2008 to that in 2010?
Provide a succinct answer. 1.67. What is the ratio of the Emissions (1000 metric ton of CO2 equivalent) of United Kingdom in 2008 to that in 2010?
Offer a very short reply. 2.56. What is the difference between the highest and the second highest Emissions (1000 metric ton of CO2 equivalent) in Algeria?
Offer a terse response. 324.4. What is the difference between the highest and the second highest Emissions (1000 metric ton of CO2 equivalent) in Finland?
Your answer should be compact. 91.5. What is the difference between the highest and the second highest Emissions (1000 metric ton of CO2 equivalent) of Israel?
Give a very brief answer. 19.5. What is the difference between the highest and the second highest Emissions (1000 metric ton of CO2 equivalent) of United Kingdom?
Your answer should be compact. 1.70e+04. What is the difference between the highest and the lowest Emissions (1000 metric ton of CO2 equivalent) of Algeria?
Make the answer very short. 1157.2. What is the difference between the highest and the lowest Emissions (1000 metric ton of CO2 equivalent) of Finland?
Ensure brevity in your answer.  1466.1. What is the difference between the highest and the lowest Emissions (1000 metric ton of CO2 equivalent) in Israel?
Keep it short and to the point. 250.5. What is the difference between the highest and the lowest Emissions (1000 metric ton of CO2 equivalent) of United Kingdom?
Offer a terse response. 2.12e+04. 